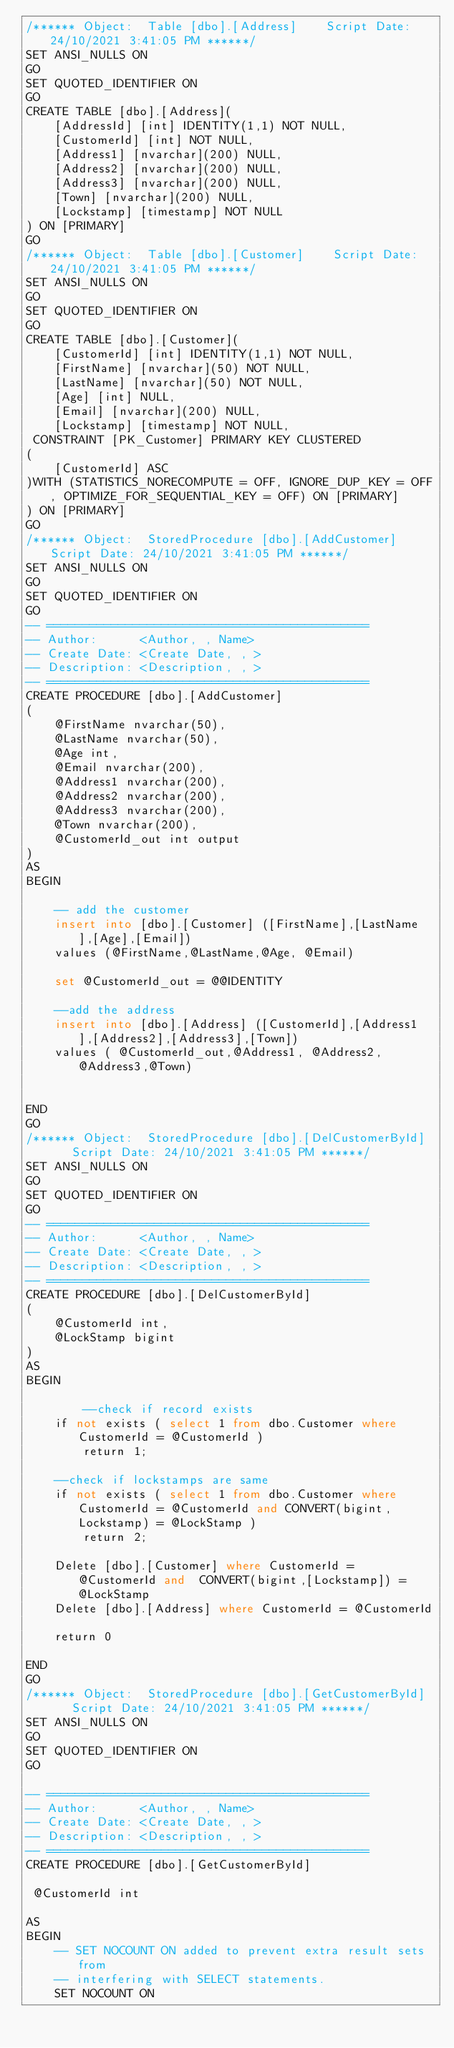<code> <loc_0><loc_0><loc_500><loc_500><_SQL_>/****** Object:  Table [dbo].[Address]    Script Date: 24/10/2021 3:41:05 PM ******/
SET ANSI_NULLS ON
GO
SET QUOTED_IDENTIFIER ON
GO
CREATE TABLE [dbo].[Address](
	[AddressId] [int] IDENTITY(1,1) NOT NULL,
	[CustomerId] [int] NOT NULL,
	[Address1] [nvarchar](200) NULL,
	[Address2] [nvarchar](200) NULL,
	[Address3] [nvarchar](200) NULL,
	[Town] [nvarchar](200) NULL,
	[Lockstamp] [timestamp] NOT NULL
) ON [PRIMARY]
GO
/****** Object:  Table [dbo].[Customer]    Script Date: 24/10/2021 3:41:05 PM ******/
SET ANSI_NULLS ON
GO
SET QUOTED_IDENTIFIER ON
GO
CREATE TABLE [dbo].[Customer](
	[CustomerId] [int] IDENTITY(1,1) NOT NULL,
	[FirstName] [nvarchar](50) NOT NULL,
	[LastName] [nvarchar](50) NOT NULL,
	[Age] [int] NULL,
	[Email] [nvarchar](200) NULL,
	[Lockstamp] [timestamp] NOT NULL,
 CONSTRAINT [PK_Customer] PRIMARY KEY CLUSTERED 
(
	[CustomerId] ASC
)WITH (STATISTICS_NORECOMPUTE = OFF, IGNORE_DUP_KEY = OFF, OPTIMIZE_FOR_SEQUENTIAL_KEY = OFF) ON [PRIMARY]
) ON [PRIMARY]
GO
/****** Object:  StoredProcedure [dbo].[AddCustomer]    Script Date: 24/10/2021 3:41:05 PM ******/
SET ANSI_NULLS ON
GO
SET QUOTED_IDENTIFIER ON
GO
-- =============================================
-- Author:      <Author, , Name>
-- Create Date: <Create Date, , >
-- Description: <Description, , >
-- =============================================
CREATE PROCEDURE [dbo].[AddCustomer]
(
	@FirstName nvarchar(50),
	@LastName nvarchar(50),
	@Age int,
	@Email nvarchar(200),
	@Address1 nvarchar(200),
	@Address2 nvarchar(200),
	@Address3 nvarchar(200),
	@Town nvarchar(200),
	@CustomerId_out int output
)
AS
BEGIN
    
	-- add the customer 
    insert into [dbo].[Customer] ([FirstName],[LastName],[Age],[Email])
	values (@FirstName,@LastName,@Age, @Email)

	set @CustomerId_out = @@IDENTITY

	--add the address
	insert into [dbo].[Address] ([CustomerId],[Address1],[Address2],[Address3],[Town])
	values ( @CustomerId_out,@Address1, @Address2, @Address3,@Town)

    
END
GO
/****** Object:  StoredProcedure [dbo].[DelCustomerById]    Script Date: 24/10/2021 3:41:05 PM ******/
SET ANSI_NULLS ON
GO
SET QUOTED_IDENTIFIER ON
GO
-- =============================================
-- Author:      <Author, , Name>
-- Create Date: <Create Date, , >
-- Description: <Description, , >
-- =============================================
CREATE PROCEDURE [dbo].[DelCustomerById]
(
	@CustomerId int,
	@LockStamp bigint
)
AS
BEGIN
    
		--check if record exists
	if not exists ( select 1 from dbo.Customer where  CustomerId = @CustomerId )
		return 1;

	--check if lockstamps are same
	if not exists ( select 1 from dbo.Customer where  CustomerId = @CustomerId and CONVERT(bigint,Lockstamp) = @LockStamp )
		return 2;
	
    Delete [dbo].[Customer] where CustomerId = @CustomerId and  CONVERT(bigint,[Lockstamp]) = @LockStamp
	Delete [dbo].[Address] where CustomerId = @CustomerId

	return 0
			
END
GO
/****** Object:  StoredProcedure [dbo].[GetCustomerById]    Script Date: 24/10/2021 3:41:05 PM ******/
SET ANSI_NULLS ON
GO
SET QUOTED_IDENTIFIER ON
GO

-- =============================================
-- Author:      <Author, , Name>
-- Create Date: <Create Date, , >
-- Description: <Description, , >
-- =============================================
CREATE PROCEDURE [dbo].[GetCustomerById]

 @CustomerId int
 
AS
BEGIN
    -- SET NOCOUNT ON added to prevent extra result sets from
    -- interfering with SELECT statements.
    SET NOCOUNT ON
</code> 